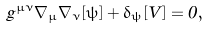Convert formula to latex. <formula><loc_0><loc_0><loc_500><loc_500>\hat { g } ^ { \mu \nu } \hat { \nabla } _ { \mu } \hat { \nabla } _ { \nu } [ \psi ] + \delta _ { \psi } [ \hat { V } ] = 0 ,</formula> 